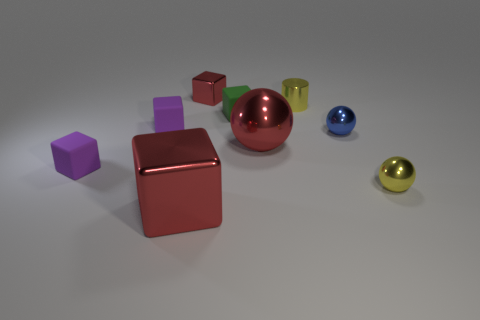What is the material of the object that is the same color as the small cylinder?
Your response must be concise. Metal. Is there a small red block that has the same material as the tiny red object?
Keep it short and to the point. No. The metallic sphere that is the same color as the tiny shiny cylinder is what size?
Provide a succinct answer. Small. Are there fewer small shiny cubes than metal blocks?
Your answer should be very brief. Yes. There is a shiny sphere that is to the left of the small metal cylinder; does it have the same color as the tiny shiny block?
Offer a terse response. Yes. What is the red block that is in front of the purple rubber thing in front of the small metal ball that is behind the large sphere made of?
Ensure brevity in your answer.  Metal. Are there any small things that have the same color as the metal cylinder?
Your answer should be very brief. Yes. Are there fewer cylinders right of the cylinder than small yellow things?
Offer a very short reply. Yes. Do the red metal cube behind the green matte thing and the big metallic block have the same size?
Offer a very short reply. No. What number of things are right of the yellow cylinder and to the left of the big red block?
Ensure brevity in your answer.  0. 